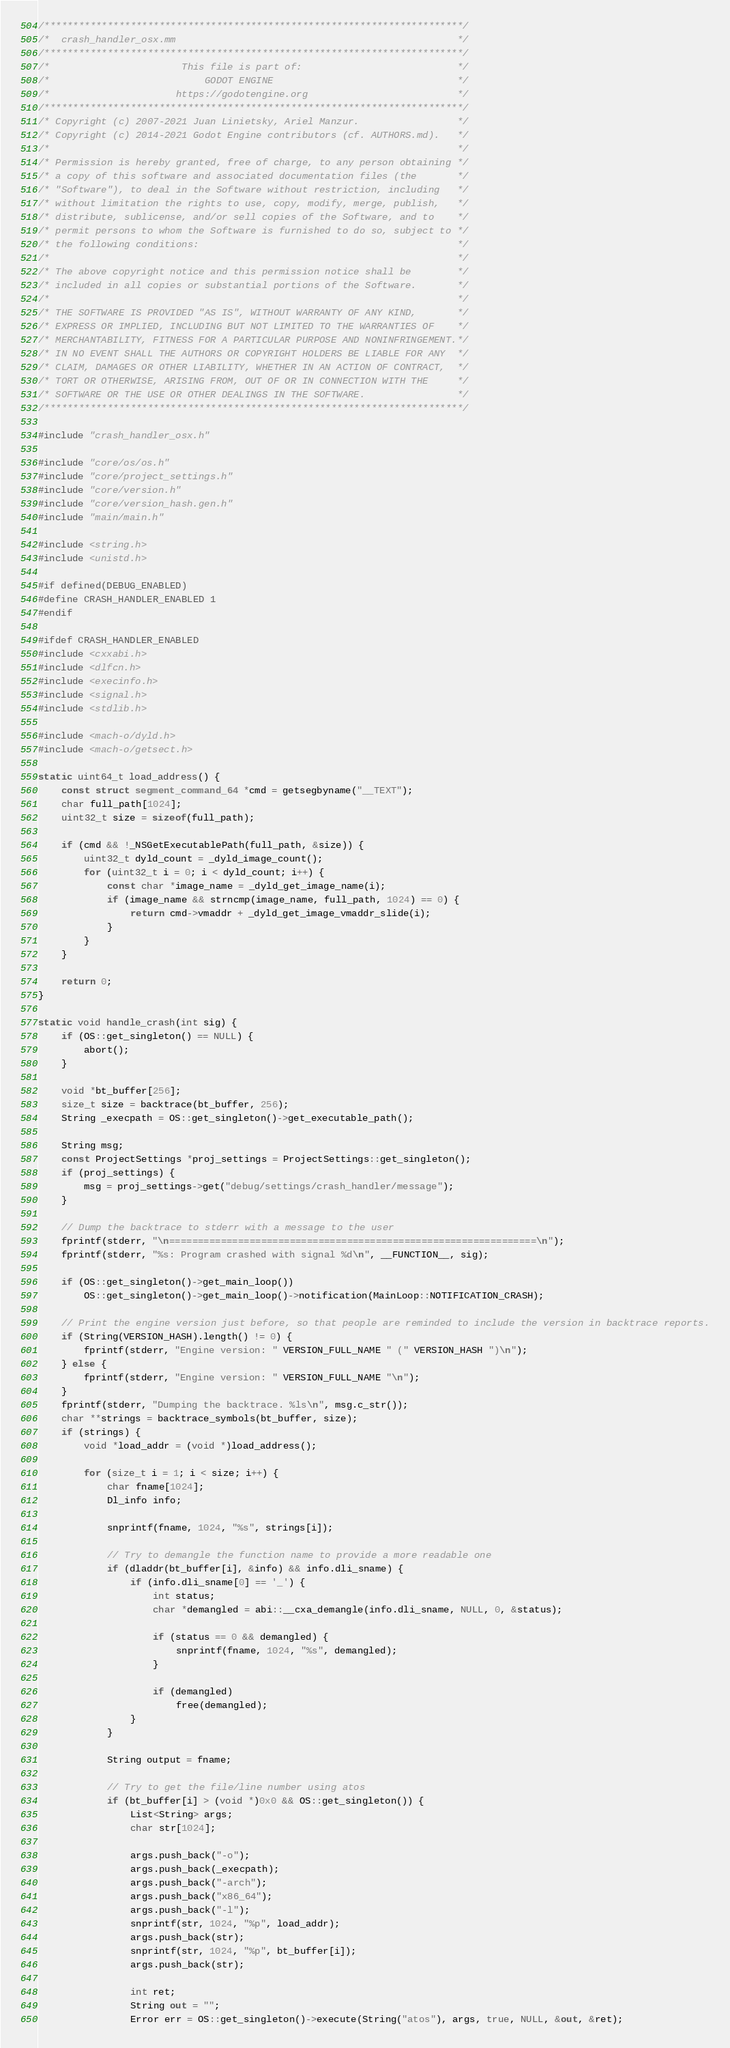<code> <loc_0><loc_0><loc_500><loc_500><_ObjectiveC_>/*************************************************************************/
/*  crash_handler_osx.mm                                                 */
/*************************************************************************/
/*                       This file is part of:                           */
/*                           GODOT ENGINE                                */
/*                      https://godotengine.org                          */
/*************************************************************************/
/* Copyright (c) 2007-2021 Juan Linietsky, Ariel Manzur.                 */
/* Copyright (c) 2014-2021 Godot Engine contributors (cf. AUTHORS.md).   */
/*                                                                       */
/* Permission is hereby granted, free of charge, to any person obtaining */
/* a copy of this software and associated documentation files (the       */
/* "Software"), to deal in the Software without restriction, including   */
/* without limitation the rights to use, copy, modify, merge, publish,   */
/* distribute, sublicense, and/or sell copies of the Software, and to    */
/* permit persons to whom the Software is furnished to do so, subject to */
/* the following conditions:                                             */
/*                                                                       */
/* The above copyright notice and this permission notice shall be        */
/* included in all copies or substantial portions of the Software.       */
/*                                                                       */
/* THE SOFTWARE IS PROVIDED "AS IS", WITHOUT WARRANTY OF ANY KIND,       */
/* EXPRESS OR IMPLIED, INCLUDING BUT NOT LIMITED TO THE WARRANTIES OF    */
/* MERCHANTABILITY, FITNESS FOR A PARTICULAR PURPOSE AND NONINFRINGEMENT.*/
/* IN NO EVENT SHALL THE AUTHORS OR COPYRIGHT HOLDERS BE LIABLE FOR ANY  */
/* CLAIM, DAMAGES OR OTHER LIABILITY, WHETHER IN AN ACTION OF CONTRACT,  */
/* TORT OR OTHERWISE, ARISING FROM, OUT OF OR IN CONNECTION WITH THE     */
/* SOFTWARE OR THE USE OR OTHER DEALINGS IN THE SOFTWARE.                */
/*************************************************************************/

#include "crash_handler_osx.h"

#include "core/os/os.h"
#include "core/project_settings.h"
#include "core/version.h"
#include "core/version_hash.gen.h"
#include "main/main.h"

#include <string.h>
#include <unistd.h>

#if defined(DEBUG_ENABLED)
#define CRASH_HANDLER_ENABLED 1
#endif

#ifdef CRASH_HANDLER_ENABLED
#include <cxxabi.h>
#include <dlfcn.h>
#include <execinfo.h>
#include <signal.h>
#include <stdlib.h>

#include <mach-o/dyld.h>
#include <mach-o/getsect.h>

static uint64_t load_address() {
	const struct segment_command_64 *cmd = getsegbyname("__TEXT");
	char full_path[1024];
	uint32_t size = sizeof(full_path);

	if (cmd && !_NSGetExecutablePath(full_path, &size)) {
		uint32_t dyld_count = _dyld_image_count();
		for (uint32_t i = 0; i < dyld_count; i++) {
			const char *image_name = _dyld_get_image_name(i);
			if (image_name && strncmp(image_name, full_path, 1024) == 0) {
				return cmd->vmaddr + _dyld_get_image_vmaddr_slide(i);
			}
		}
	}

	return 0;
}

static void handle_crash(int sig) {
	if (OS::get_singleton() == NULL) {
		abort();
	}

	void *bt_buffer[256];
	size_t size = backtrace(bt_buffer, 256);
	String _execpath = OS::get_singleton()->get_executable_path();

	String msg;
	const ProjectSettings *proj_settings = ProjectSettings::get_singleton();
	if (proj_settings) {
		msg = proj_settings->get("debug/settings/crash_handler/message");
	}

	// Dump the backtrace to stderr with a message to the user
	fprintf(stderr, "\n================================================================\n");
	fprintf(stderr, "%s: Program crashed with signal %d\n", __FUNCTION__, sig);

	if (OS::get_singleton()->get_main_loop())
		OS::get_singleton()->get_main_loop()->notification(MainLoop::NOTIFICATION_CRASH);

	// Print the engine version just before, so that people are reminded to include the version in backtrace reports.
	if (String(VERSION_HASH).length() != 0) {
		fprintf(stderr, "Engine version: " VERSION_FULL_NAME " (" VERSION_HASH ")\n");
	} else {
		fprintf(stderr, "Engine version: " VERSION_FULL_NAME "\n");
	}
	fprintf(stderr, "Dumping the backtrace. %ls\n", msg.c_str());
	char **strings = backtrace_symbols(bt_buffer, size);
	if (strings) {
		void *load_addr = (void *)load_address();

		for (size_t i = 1; i < size; i++) {
			char fname[1024];
			Dl_info info;

			snprintf(fname, 1024, "%s", strings[i]);

			// Try to demangle the function name to provide a more readable one
			if (dladdr(bt_buffer[i], &info) && info.dli_sname) {
				if (info.dli_sname[0] == '_') {
					int status;
					char *demangled = abi::__cxa_demangle(info.dli_sname, NULL, 0, &status);

					if (status == 0 && demangled) {
						snprintf(fname, 1024, "%s", demangled);
					}

					if (demangled)
						free(demangled);
				}
			}

			String output = fname;

			// Try to get the file/line number using atos
			if (bt_buffer[i] > (void *)0x0 && OS::get_singleton()) {
				List<String> args;
				char str[1024];

				args.push_back("-o");
				args.push_back(_execpath);
				args.push_back("-arch");
				args.push_back("x86_64");
				args.push_back("-l");
				snprintf(str, 1024, "%p", load_addr);
				args.push_back(str);
				snprintf(str, 1024, "%p", bt_buffer[i]);
				args.push_back(str);

				int ret;
				String out = "";
				Error err = OS::get_singleton()->execute(String("atos"), args, true, NULL, &out, &ret);</code> 